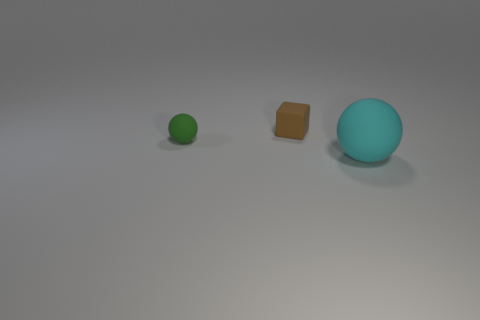What number of brown rubber cylinders have the same size as the brown cube?
Your answer should be very brief. 0. There is a matte thing that is on the left side of the brown matte object; what color is it?
Provide a succinct answer. Green. What number of other things are there of the same size as the brown thing?
Give a very brief answer. 1. What is the size of the matte thing that is both right of the green thing and in front of the brown object?
Your answer should be very brief. Large. There is a big matte object; does it have the same color as the tiny thing that is on the left side of the tiny rubber block?
Ensure brevity in your answer.  No. Is there another cyan thing of the same shape as the big cyan object?
Ensure brevity in your answer.  No. How many objects are either brown cubes or matte objects that are to the left of the small rubber cube?
Offer a very short reply. 2. What number of other things are there of the same material as the large thing
Your answer should be very brief. 2. What number of things are either cyan spheres or shiny cubes?
Your answer should be compact. 1. Is the number of large cyan rubber things that are right of the big sphere greater than the number of rubber objects to the left of the brown matte thing?
Your answer should be compact. No. 